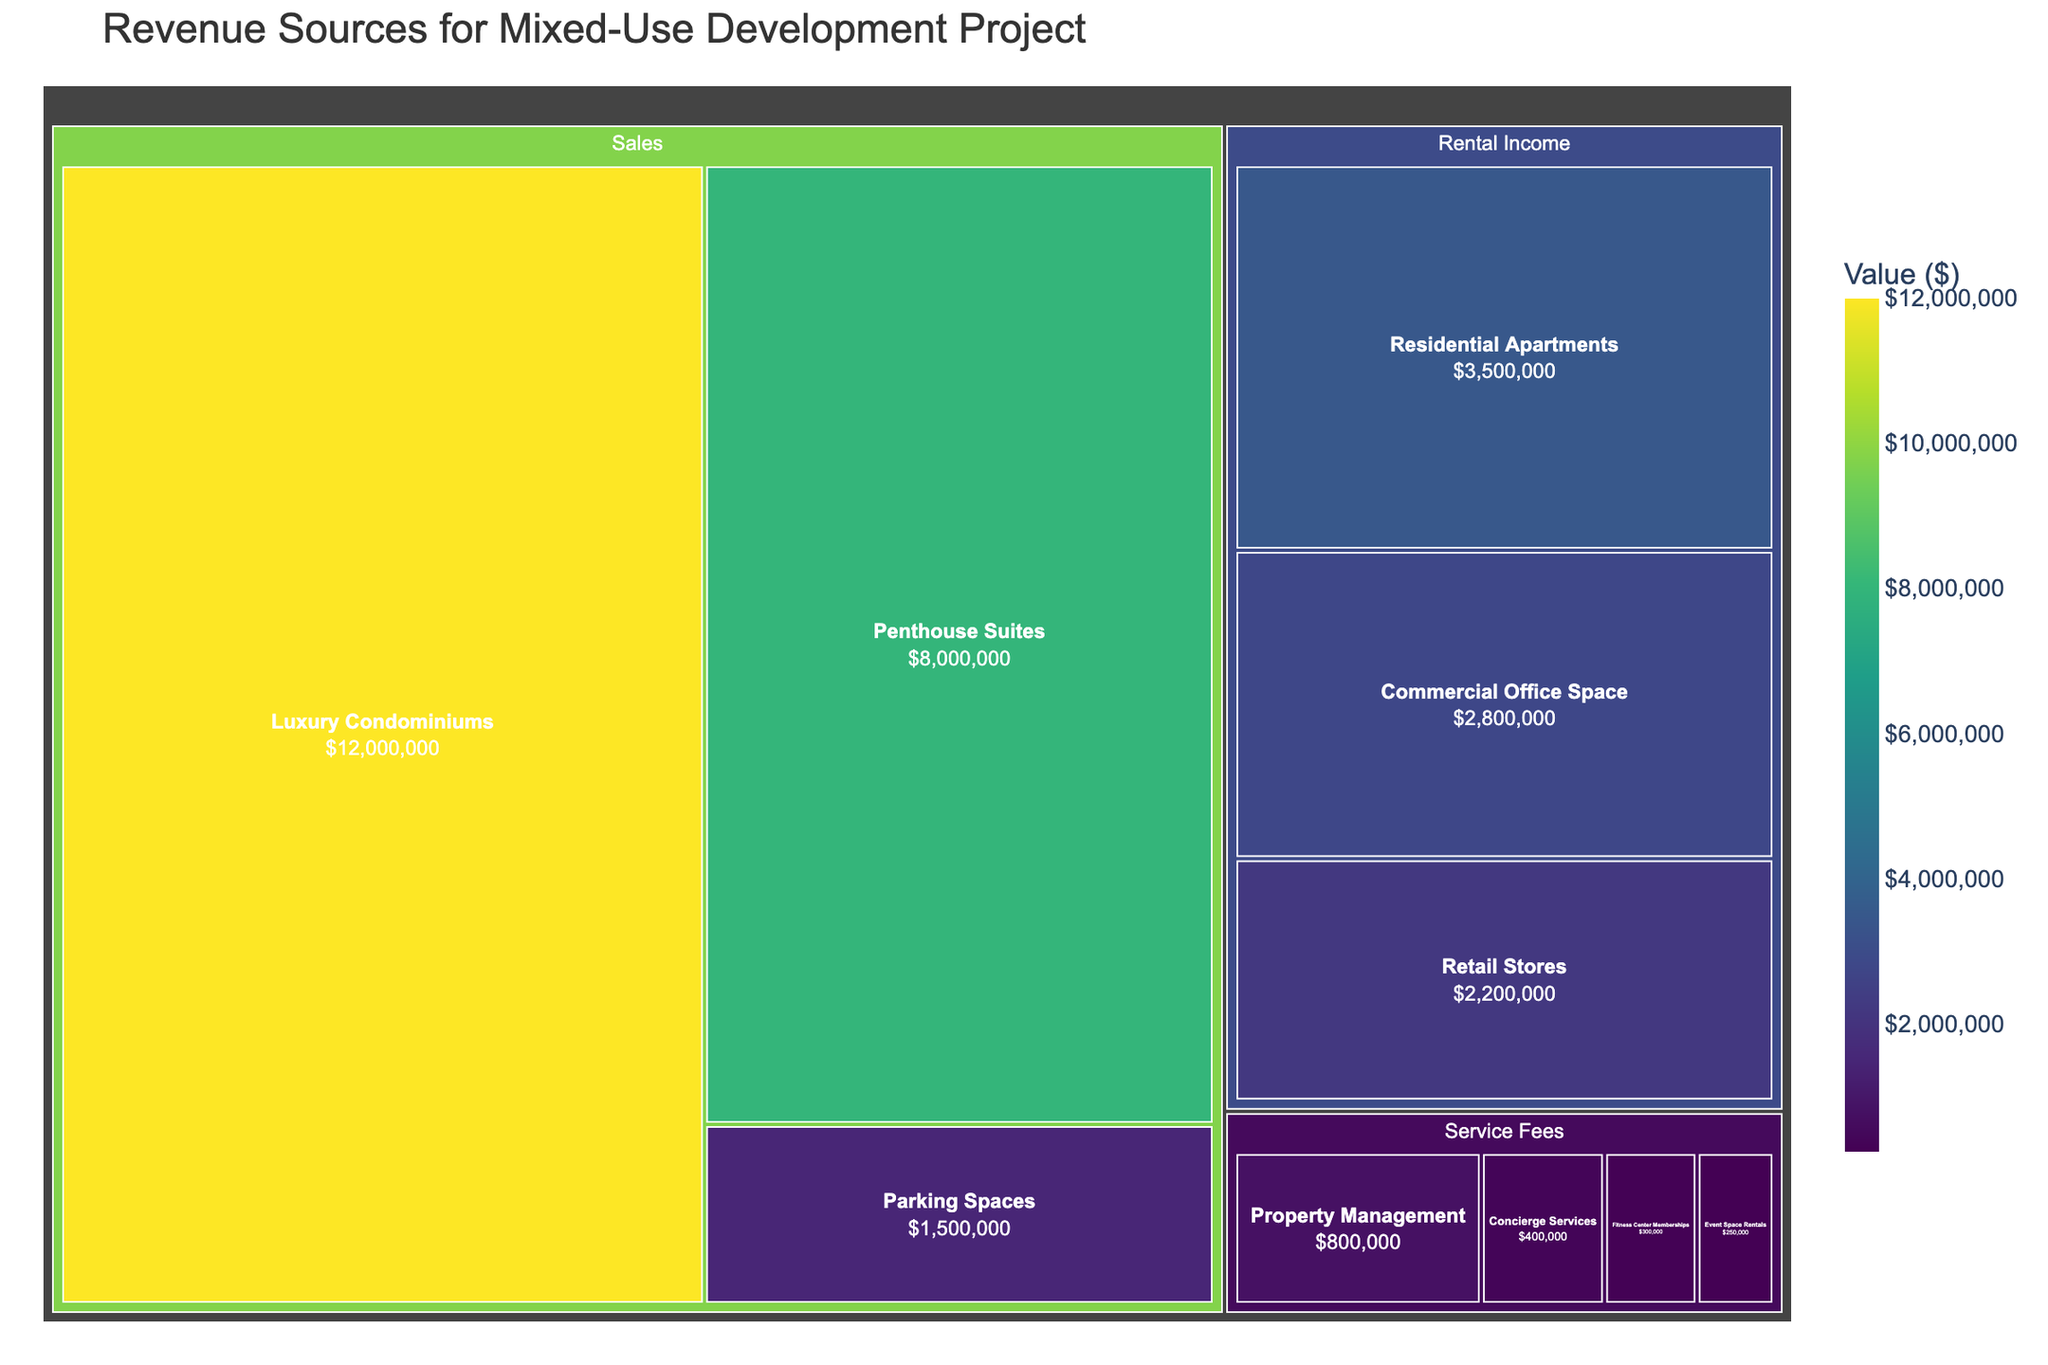What's the largest revenue source? The largest block on the Treemap is "Luxury Condominiums" under the Sales category. This block has the highest value displayed.
Answer: Luxury Condominiums How much total revenue does the "Sales" category generate? Sum up all the values under the Sales category: 12,000,000 (Luxury Condominiums) + 8,000,000 (Penthouse Suites) + 1,500,000 (Parking Spaces) = 21,500,000.
Answer: $21,500,000 Which subcategory has the lowest revenue under "Service Fees"? The smallest block under the "Service Fees" category is "Event Space Rentals," which has the lowest value displayed.
Answer: Event Space Rentals Compare the revenue from "Residential Apartments" and "Retail Stores". Which one is higher? The "Residential Apartments" has a revenue of 3,500,000, while "Retail Stores" has 2,200,000. Therefore, "Residential Apartments" has a higher revenue.
Answer: Residential Apartments What's the combined revenue of "Rental Income" and "Service Fees"? First, sum up all the values under each category:
Rental Income: 3,500,000 (Residential Apartments) + 2,800,000 (Commercial Office Space) + 2,200,000 (Retail Stores) = 8,500,000
Service Fees: 800,000 (Property Management) + 400,000 (Concierge Services) + 300,000 (Fitness Center Memberships) + 250,000 (Event Space Rentals) = 1,750,000
Combine them: 8,500,000 + 1,750,000 = 10,250,000
Answer: $10,250,000 Is the revenue from "Penthouse Suites" greater than the combined revenue of all "Service Fees" subcategories? The revenue from "Penthouse Suites" is 8,000,000. The combined revenue of all "Service Fees" subcategories is 1,750,000. Since 8,000,000 > 1,750,000, the revenue from "Penthouse Suites" is greater.
Answer: Yes What is the total revenue generated by all subcategories under "Rental Income"? Sum up all the values under the "Rental Income" category: 3,500,000 (Residential Apartments) + 2,800,000 (Commercial Office Space) + 2,200,000 (Retail Stores) = 8,500,000.
Answer: $8,500,000 If revenue from "Event Space Rentals" doubled, how would it compare to "Residential Apartments"? The current revenue from "Event Space Rentals" is 250,000. Doubling it would make it 500,000. "Residential Apartments" has a revenue of 3,500,000. Since 500,000 < 3,500,000, "Residential Apartments" would still have a higher revenue.
Answer: Residential Apartments Which "Sales" subcategory is the second largest in revenue? The second largest block under the Sales category is "Penthouse Suites" with a revenue of 8,000,000.
Answer: Penthouse Suites 